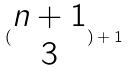Convert formula to latex. <formula><loc_0><loc_0><loc_500><loc_500>( \begin{matrix} n + 1 \\ 3 \end{matrix} ) + 1</formula> 